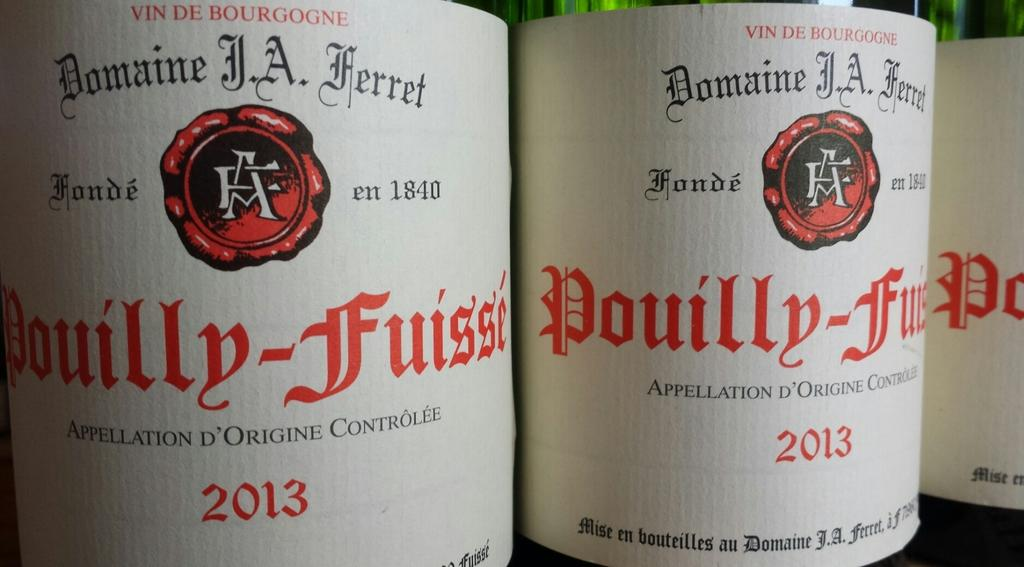<image>
Share a concise interpretation of the image provided. A closeup of Pouilly-Fuisse bottles show they were made in 2013. 